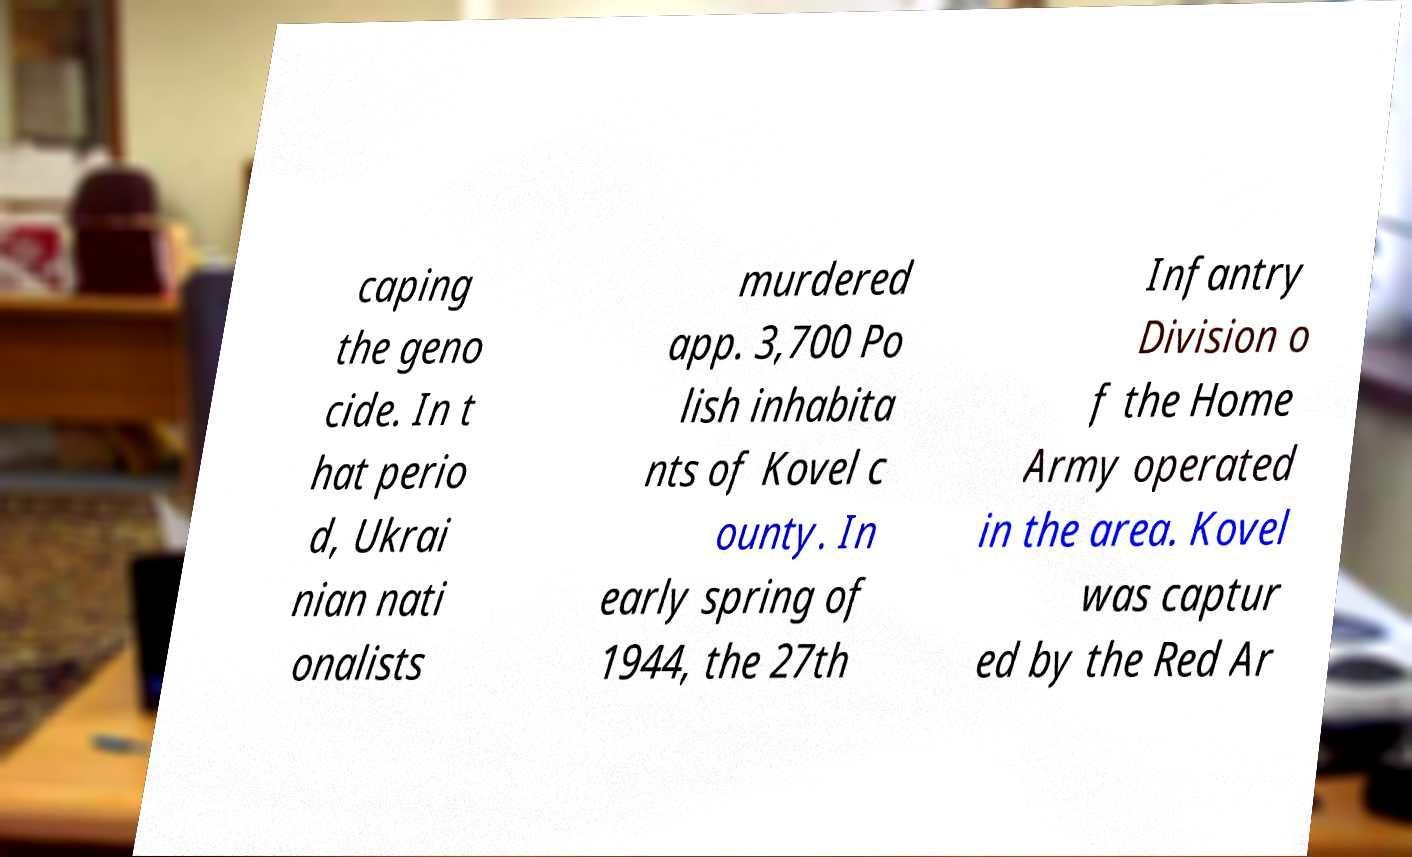Please read and relay the text visible in this image. What does it say? caping the geno cide. In t hat perio d, Ukrai nian nati onalists murdered app. 3,700 Po lish inhabita nts of Kovel c ounty. In early spring of 1944, the 27th Infantry Division o f the Home Army operated in the area. Kovel was captur ed by the Red Ar 